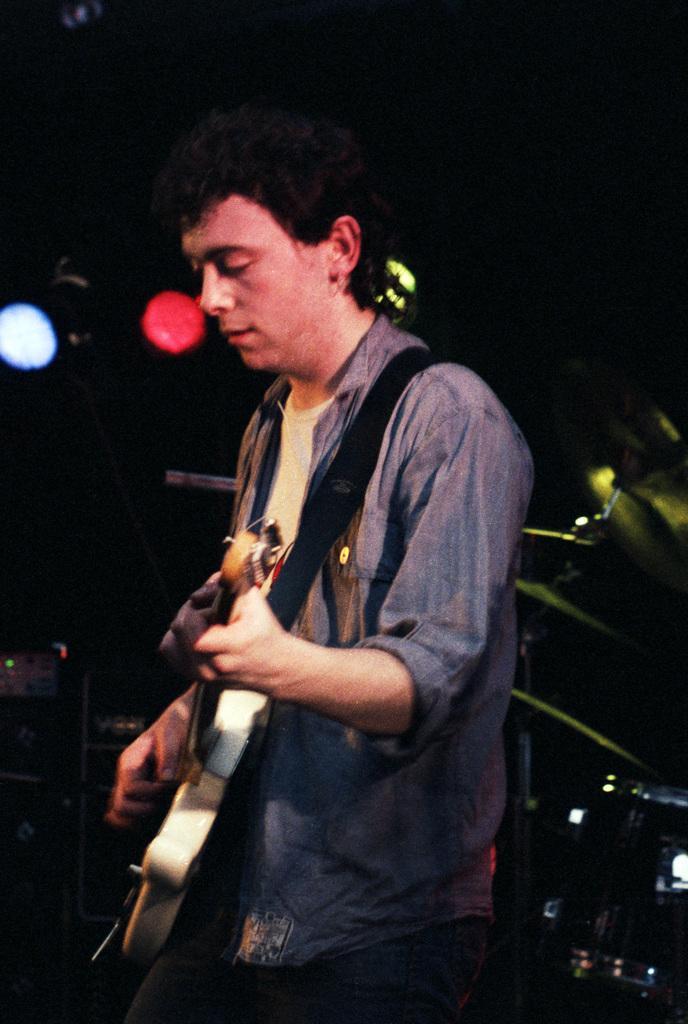In one or two sentences, can you explain what this image depicts? In this image In the middle there is a man he is playing guitar he wear shirt, trouser and t shirt. In the background there are lights. 